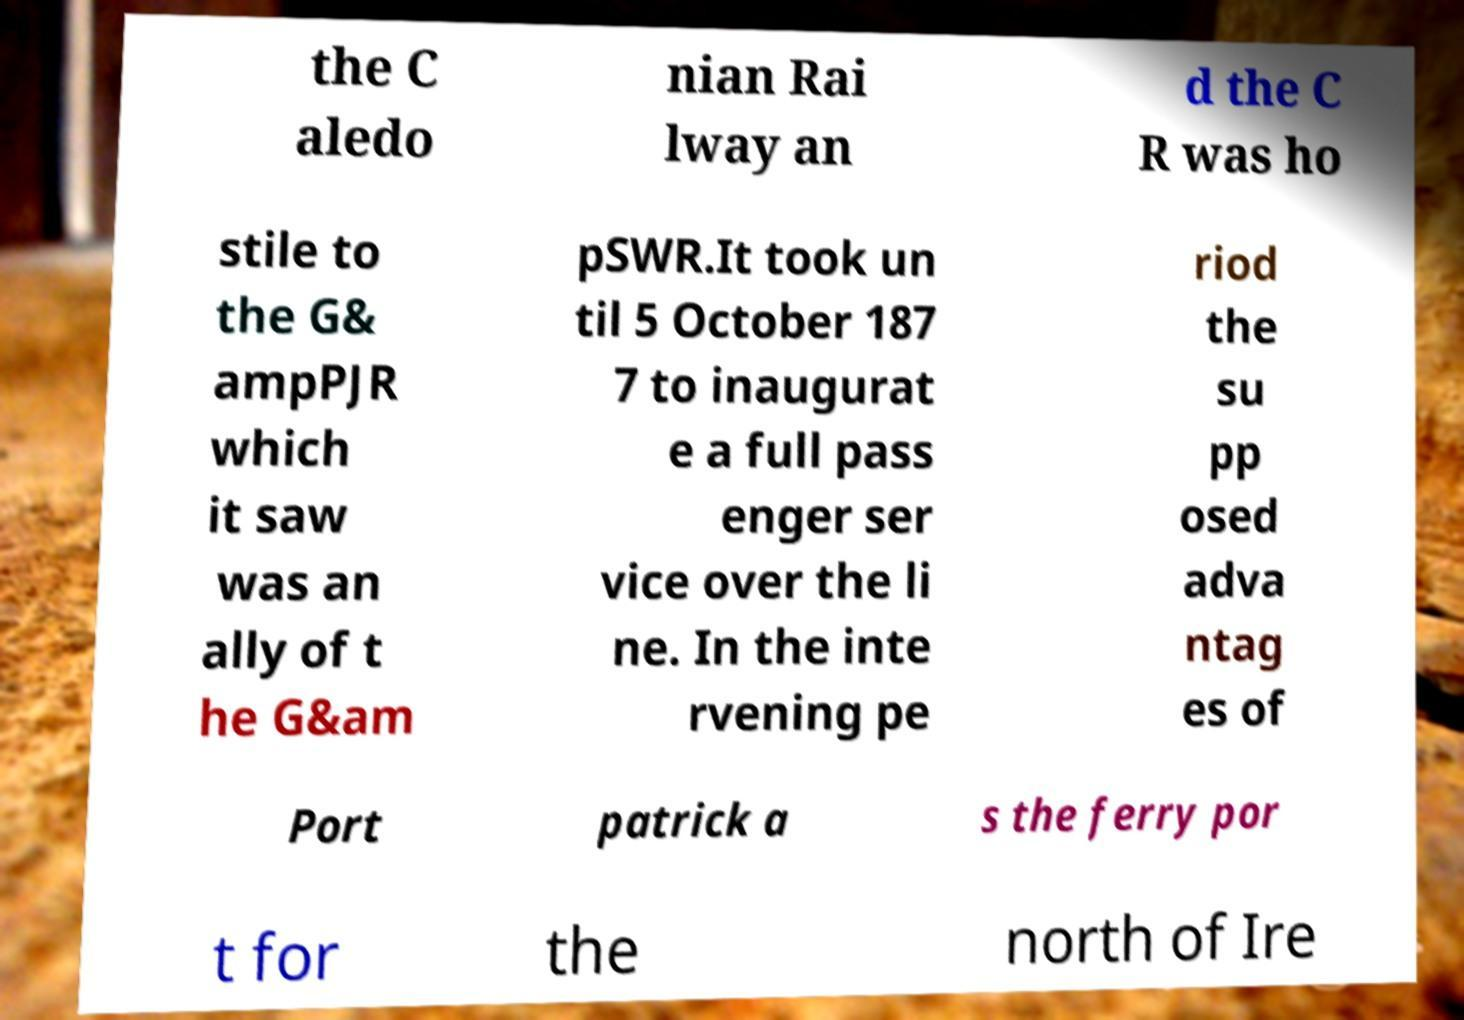I need the written content from this picture converted into text. Can you do that? the C aledo nian Rai lway an d the C R was ho stile to the G& ampPJR which it saw was an ally of t he G&am pSWR.It took un til 5 October 187 7 to inaugurat e a full pass enger ser vice over the li ne. In the inte rvening pe riod the su pp osed adva ntag es of Port patrick a s the ferry por t for the north of Ire 